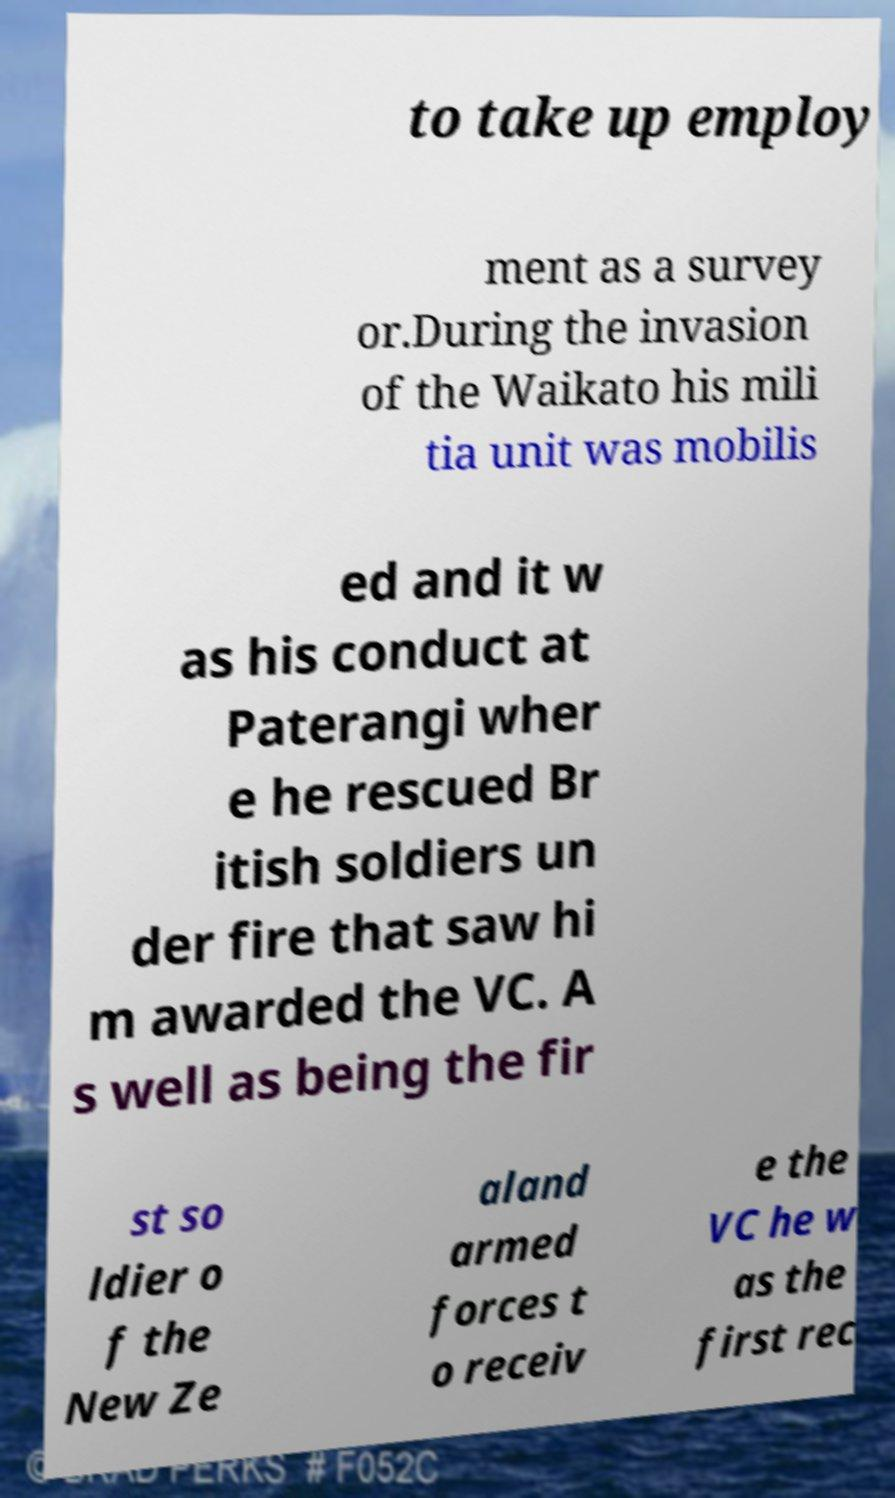I need the written content from this picture converted into text. Can you do that? to take up employ ment as a survey or.During the invasion of the Waikato his mili tia unit was mobilis ed and it w as his conduct at Paterangi wher e he rescued Br itish soldiers un der fire that saw hi m awarded the VC. A s well as being the fir st so ldier o f the New Ze aland armed forces t o receiv e the VC he w as the first rec 